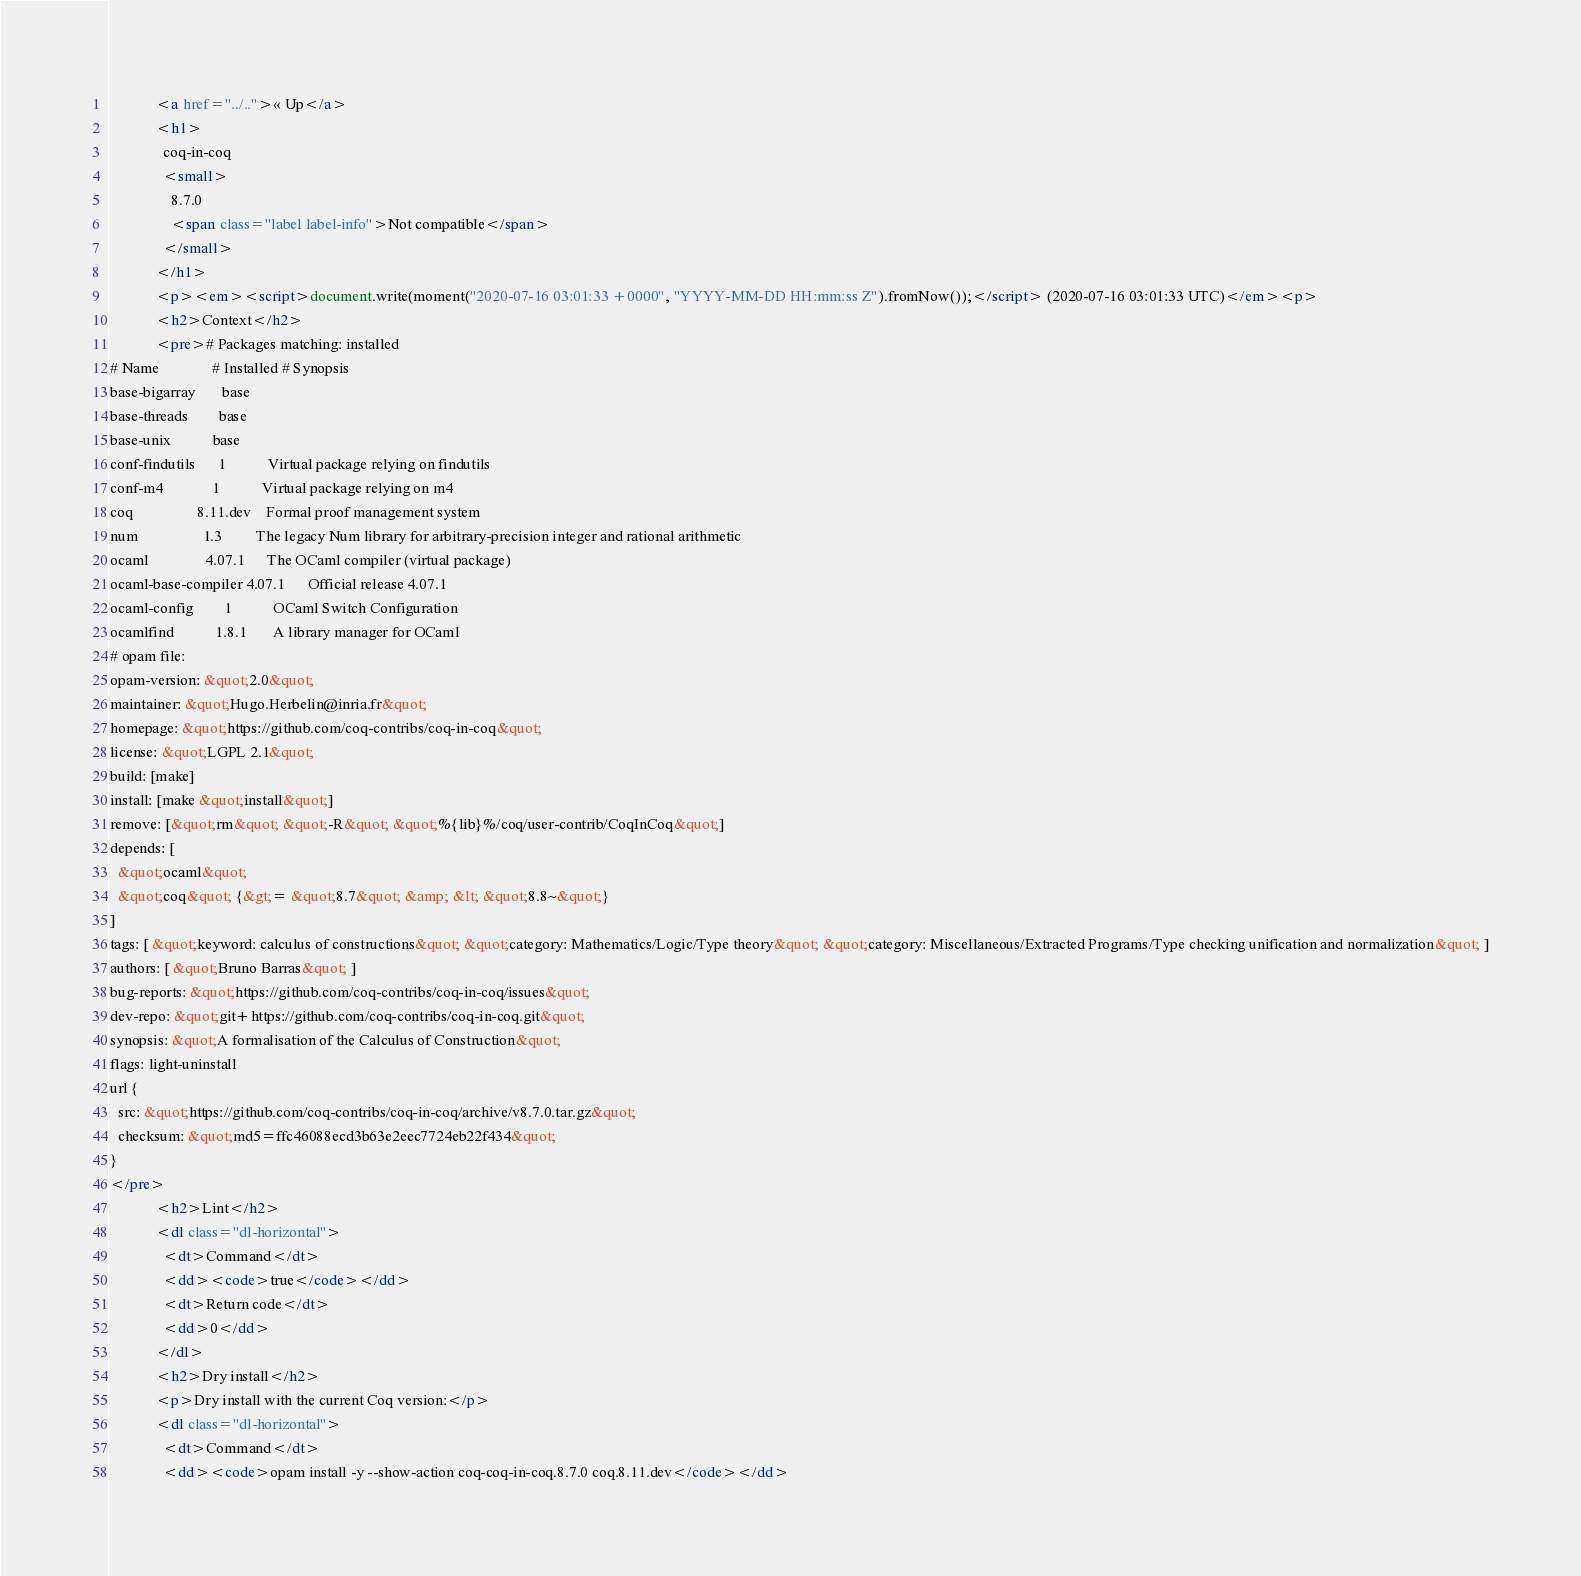<code> <loc_0><loc_0><loc_500><loc_500><_HTML_>            <a href="../..">« Up</a>
            <h1>
              coq-in-coq
              <small>
                8.7.0
                <span class="label label-info">Not compatible</span>
              </small>
            </h1>
            <p><em><script>document.write(moment("2020-07-16 03:01:33 +0000", "YYYY-MM-DD HH:mm:ss Z").fromNow());</script> (2020-07-16 03:01:33 UTC)</em><p>
            <h2>Context</h2>
            <pre># Packages matching: installed
# Name              # Installed # Synopsis
base-bigarray       base
base-threads        base
base-unix           base
conf-findutils      1           Virtual package relying on findutils
conf-m4             1           Virtual package relying on m4
coq                 8.11.dev    Formal proof management system
num                 1.3         The legacy Num library for arbitrary-precision integer and rational arithmetic
ocaml               4.07.1      The OCaml compiler (virtual package)
ocaml-base-compiler 4.07.1      Official release 4.07.1
ocaml-config        1           OCaml Switch Configuration
ocamlfind           1.8.1       A library manager for OCaml
# opam file:
opam-version: &quot;2.0&quot;
maintainer: &quot;Hugo.Herbelin@inria.fr&quot;
homepage: &quot;https://github.com/coq-contribs/coq-in-coq&quot;
license: &quot;LGPL 2.1&quot;
build: [make]
install: [make &quot;install&quot;]
remove: [&quot;rm&quot; &quot;-R&quot; &quot;%{lib}%/coq/user-contrib/CoqInCoq&quot;]
depends: [
  &quot;ocaml&quot;
  &quot;coq&quot; {&gt;= &quot;8.7&quot; &amp; &lt; &quot;8.8~&quot;}
]
tags: [ &quot;keyword: calculus of constructions&quot; &quot;category: Mathematics/Logic/Type theory&quot; &quot;category: Miscellaneous/Extracted Programs/Type checking unification and normalization&quot; ]
authors: [ &quot;Bruno Barras&quot; ]
bug-reports: &quot;https://github.com/coq-contribs/coq-in-coq/issues&quot;
dev-repo: &quot;git+https://github.com/coq-contribs/coq-in-coq.git&quot;
synopsis: &quot;A formalisation of the Calculus of Construction&quot;
flags: light-uninstall
url {
  src: &quot;https://github.com/coq-contribs/coq-in-coq/archive/v8.7.0.tar.gz&quot;
  checksum: &quot;md5=ffc46088ecd3b63e2eec7724eb22f434&quot;
}
</pre>
            <h2>Lint</h2>
            <dl class="dl-horizontal">
              <dt>Command</dt>
              <dd><code>true</code></dd>
              <dt>Return code</dt>
              <dd>0</dd>
            </dl>
            <h2>Dry install</h2>
            <p>Dry install with the current Coq version:</p>
            <dl class="dl-horizontal">
              <dt>Command</dt>
              <dd><code>opam install -y --show-action coq-coq-in-coq.8.7.0 coq.8.11.dev</code></dd></code> 